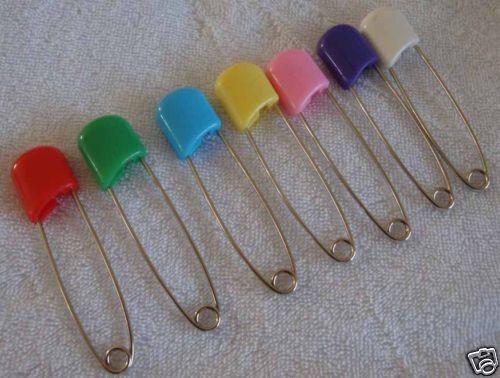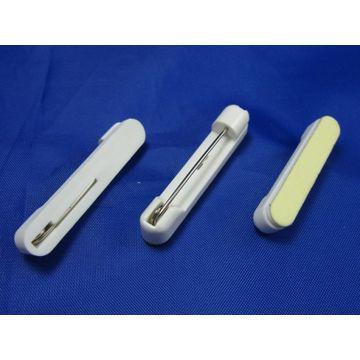The first image is the image on the left, the second image is the image on the right. Evaluate the accuracy of this statement regarding the images: "One image shows only two safety pins, one pink and one blue.". Is it true? Answer yes or no. No. 